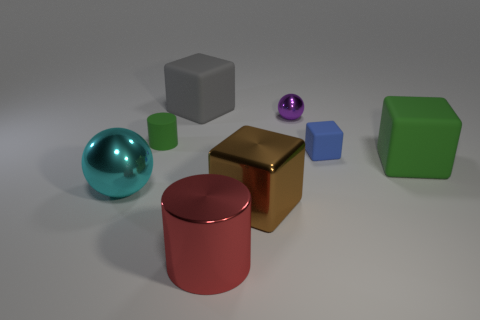What number of things are either small gray rubber things or shiny objects?
Keep it short and to the point. 4. Are there any large objects made of the same material as the gray block?
Provide a short and direct response. Yes. What is the size of the cube that is the same color as the tiny matte cylinder?
Offer a terse response. Large. What color is the ball that is to the left of the green thing that is on the left side of the large red metallic cylinder?
Provide a short and direct response. Cyan. Is the brown shiny object the same size as the green block?
Provide a short and direct response. Yes. What number of cylinders are either small yellow shiny objects or tiny purple metallic things?
Make the answer very short. 0. There is a big brown cube in front of the green rubber block; what number of tiny matte cubes are in front of it?
Your answer should be very brief. 0. Does the large brown metallic object have the same shape as the large red thing?
Offer a very short reply. No. What is the size of the green matte object that is the same shape as the tiny blue matte thing?
Ensure brevity in your answer.  Large. What is the shape of the green matte thing on the left side of the large cube that is on the left side of the big cylinder?
Make the answer very short. Cylinder. 